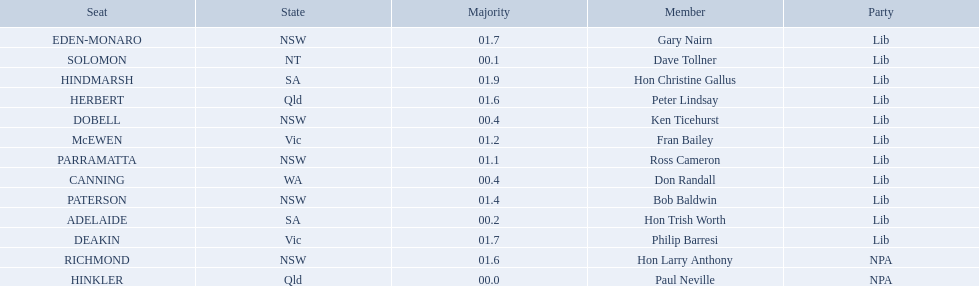Who are all the lib party members? Dave Tollner, Hon Trish Worth, Don Randall, Ken Ticehurst, Ross Cameron, Fran Bailey, Bob Baldwin, Peter Lindsay, Philip Barresi, Gary Nairn, Hon Christine Gallus. What lib party members are in sa? Hon Trish Worth, Hon Christine Gallus. What is the highest difference in majority between members in sa? 01.9. 